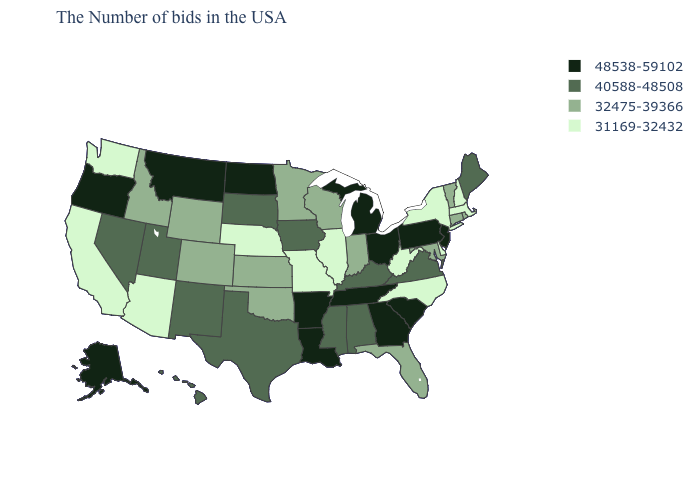Name the states that have a value in the range 40588-48508?
Give a very brief answer. Maine, Virginia, Kentucky, Alabama, Mississippi, Iowa, Texas, South Dakota, New Mexico, Utah, Nevada, Hawaii. What is the value of Hawaii?
Concise answer only. 40588-48508. Name the states that have a value in the range 32475-39366?
Quick response, please. Rhode Island, Vermont, Connecticut, Maryland, Florida, Indiana, Wisconsin, Minnesota, Kansas, Oklahoma, Wyoming, Colorado, Idaho. Name the states that have a value in the range 40588-48508?
Keep it brief. Maine, Virginia, Kentucky, Alabama, Mississippi, Iowa, Texas, South Dakota, New Mexico, Utah, Nevada, Hawaii. Name the states that have a value in the range 32475-39366?
Write a very short answer. Rhode Island, Vermont, Connecticut, Maryland, Florida, Indiana, Wisconsin, Minnesota, Kansas, Oklahoma, Wyoming, Colorado, Idaho. Name the states that have a value in the range 48538-59102?
Answer briefly. New Jersey, Pennsylvania, South Carolina, Ohio, Georgia, Michigan, Tennessee, Louisiana, Arkansas, North Dakota, Montana, Oregon, Alaska. Among the states that border Iowa , which have the highest value?
Quick response, please. South Dakota. Name the states that have a value in the range 40588-48508?
Keep it brief. Maine, Virginia, Kentucky, Alabama, Mississippi, Iowa, Texas, South Dakota, New Mexico, Utah, Nevada, Hawaii. Name the states that have a value in the range 31169-32432?
Quick response, please. Massachusetts, New Hampshire, New York, Delaware, North Carolina, West Virginia, Illinois, Missouri, Nebraska, Arizona, California, Washington. Name the states that have a value in the range 32475-39366?
Answer briefly. Rhode Island, Vermont, Connecticut, Maryland, Florida, Indiana, Wisconsin, Minnesota, Kansas, Oklahoma, Wyoming, Colorado, Idaho. Is the legend a continuous bar?
Short answer required. No. How many symbols are there in the legend?
Write a very short answer. 4. Is the legend a continuous bar?
Give a very brief answer. No. Name the states that have a value in the range 31169-32432?
Short answer required. Massachusetts, New Hampshire, New York, Delaware, North Carolina, West Virginia, Illinois, Missouri, Nebraska, Arizona, California, Washington. Name the states that have a value in the range 31169-32432?
Quick response, please. Massachusetts, New Hampshire, New York, Delaware, North Carolina, West Virginia, Illinois, Missouri, Nebraska, Arizona, California, Washington. 